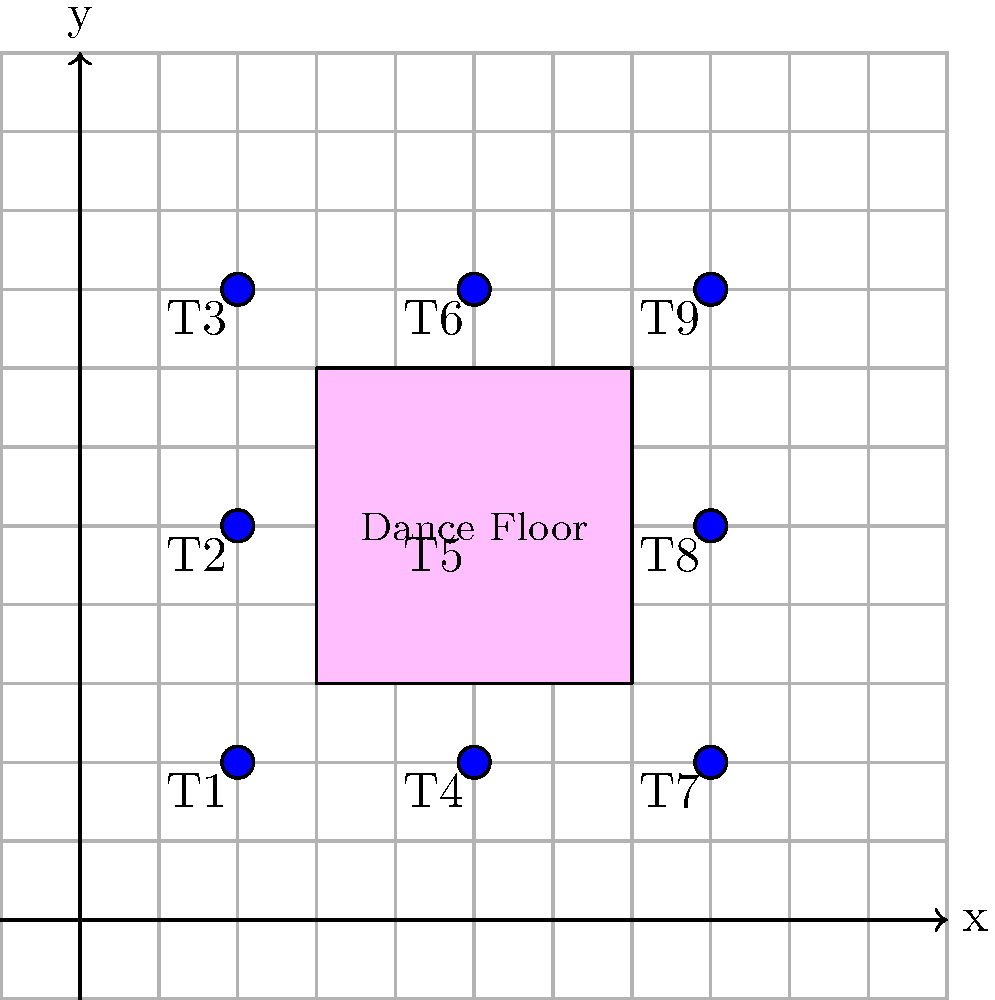As you plan your wedding seating arrangement, your grandmother suggests using a coordinate system to optimize guest placement. The reception venue is represented by a 10x10 grid, where each unit represents 1 meter. There are 9 round tables (T1 to T9) placed at coordinates (2,2), (2,5), (2,8), (5,2), (5,5), (5,8), (8,2), (8,5), and (8,8). The dance floor is a 4x4 meter square centered at (5,5). 

Your maid of honor is seated at table T2, and you want your college roommate to be as close as possible to her while still being able to quickly access the dance floor. At which table should you seat your college roommate, and what is the total distance she would need to travel to visit both your maid of honor and the center of the dance floor? Let's approach this step-by-step:

1) First, we need to identify the coordinates of the relevant points:
   - Maid of honor (T2): (2,5)
   - Center of dance floor: (5,5)

2) Now, we need to calculate the distance from each remaining table to both T2 and the dance floor center. We'll use the distance formula: $d = \sqrt{(x_2-x_1)^2 + (y_2-y_1)^2}$

3) Calculating distances:
   T1 (2,2): To T2 = 3, To dance floor = 5
   T3 (2,8): To T2 = 3, To dance floor = 5
   T4 (5,2): To T2 = 5, To dance floor = 3
   T5 (5,5): To T2 = 3, To dance floor = 0
   T6 (5,8): To T2 = 5, To dance floor = 3
   T7 (8,2): To T2 = 7.81, To dance floor = 5
   T8 (8,5): To T2 = 6, To dance floor = 3
   T9 (8,8): To T2 = 7.81, To dance floor = 5

4) The best option is T5, as it minimizes the total distance.

5) Total distance:
   - From T5 to T2: $\sqrt{(2-5)^2 + (5-5)^2} = 3$ meters
   - From T5 to dance floor center: 0 meters (already at the center)

6) Total distance = 3 + 0 = 3 meters

Therefore, you should seat your college roommate at table T5, and the total distance she would need to travel is 3 meters.
Answer: Table T5; 3 meters 